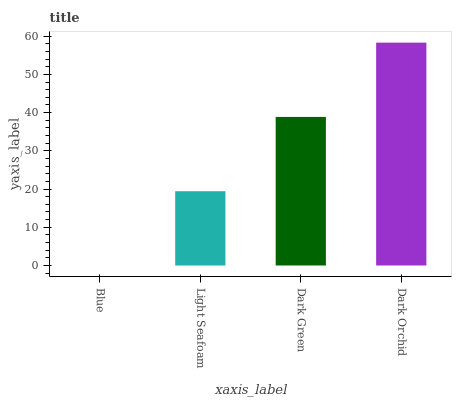Is Blue the minimum?
Answer yes or no. Yes. Is Dark Orchid the maximum?
Answer yes or no. Yes. Is Light Seafoam the minimum?
Answer yes or no. No. Is Light Seafoam the maximum?
Answer yes or no. No. Is Light Seafoam greater than Blue?
Answer yes or no. Yes. Is Blue less than Light Seafoam?
Answer yes or no. Yes. Is Blue greater than Light Seafoam?
Answer yes or no. No. Is Light Seafoam less than Blue?
Answer yes or no. No. Is Dark Green the high median?
Answer yes or no. Yes. Is Light Seafoam the low median?
Answer yes or no. Yes. Is Blue the high median?
Answer yes or no. No. Is Dark Orchid the low median?
Answer yes or no. No. 